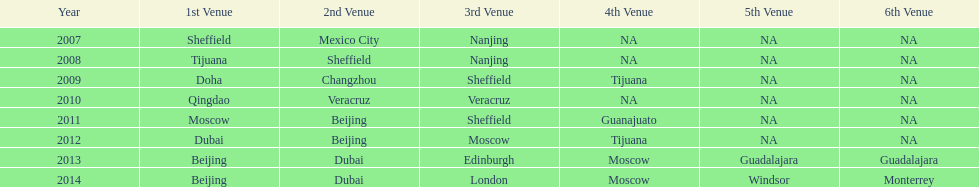Over how many years has the world series been happening? 7 years. 